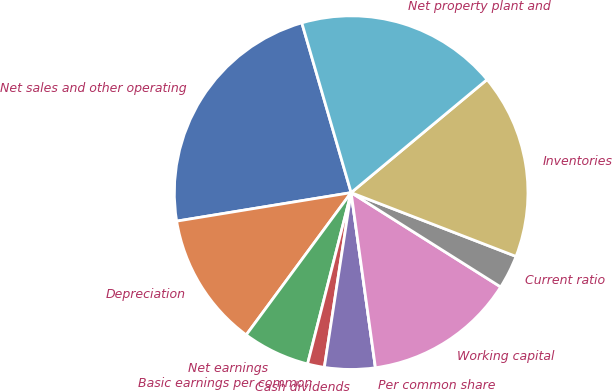<chart> <loc_0><loc_0><loc_500><loc_500><pie_chart><fcel>Net sales and other operating<fcel>Depreciation<fcel>Net earnings<fcel>Basic earnings per common<fcel>Cash dividends<fcel>Per common share<fcel>Working capital<fcel>Current ratio<fcel>Inventories<fcel>Net property plant and<nl><fcel>23.08%<fcel>12.31%<fcel>6.15%<fcel>1.54%<fcel>4.62%<fcel>0.0%<fcel>13.85%<fcel>3.08%<fcel>16.92%<fcel>18.46%<nl></chart> 